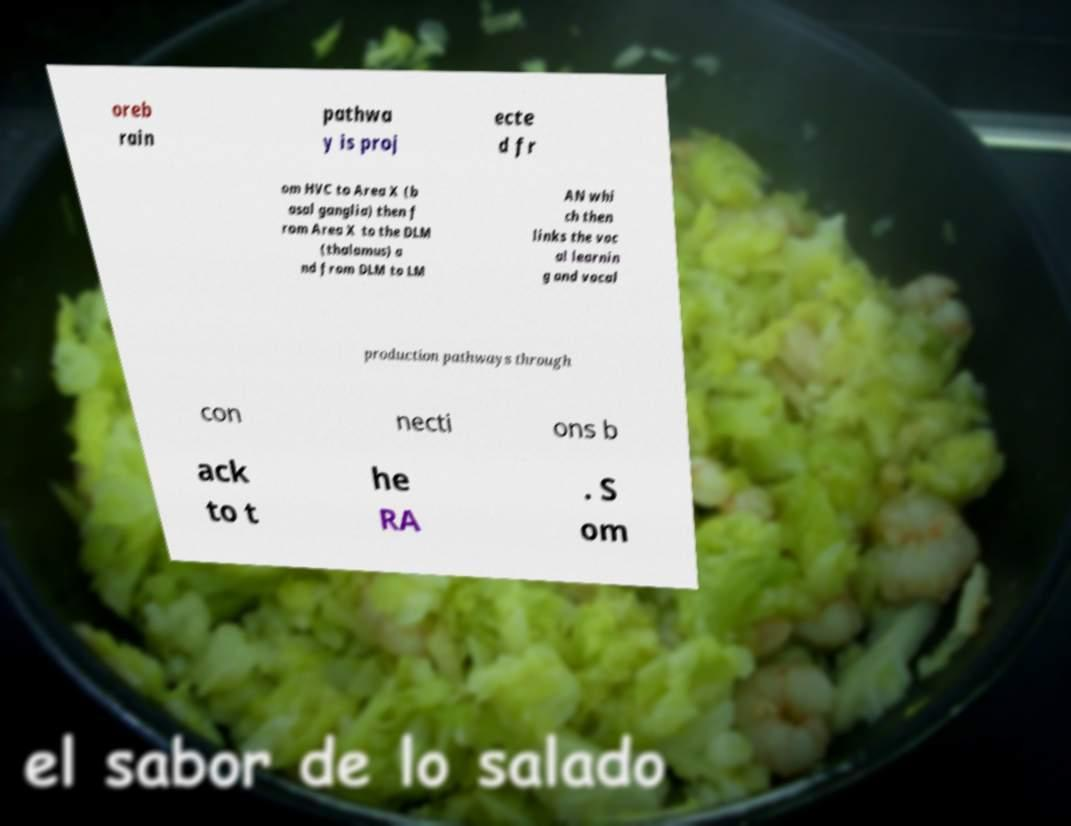Could you extract and type out the text from this image? oreb rain pathwa y is proj ecte d fr om HVC to Area X (b asal ganglia) then f rom Area X to the DLM (thalamus) a nd from DLM to LM AN whi ch then links the voc al learnin g and vocal production pathways through con necti ons b ack to t he RA . S om 